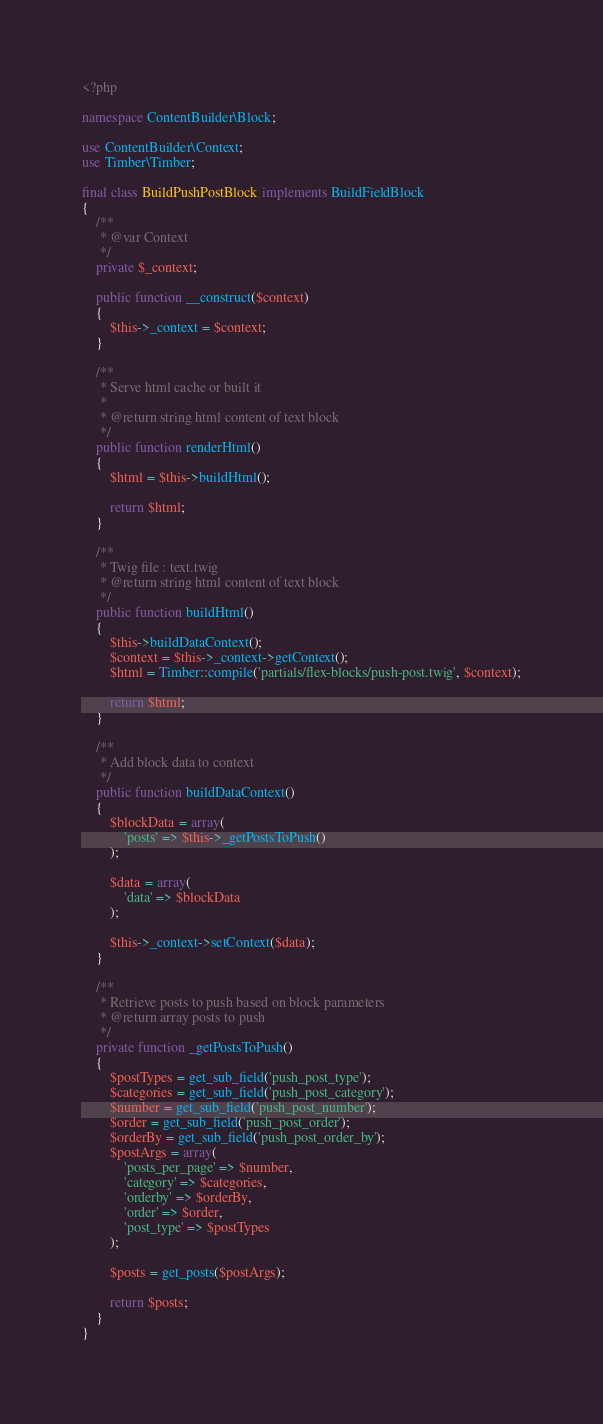Convert code to text. <code><loc_0><loc_0><loc_500><loc_500><_PHP_><?php

namespace ContentBuilder\Block;

use ContentBuilder\Context;
use Timber\Timber;

final class BuildPushPostBlock implements BuildFieldBlock
{
    /**
     * @var Context
     */
    private $_context;

    public function __construct($context)
    {
        $this->_context = $context;
    }

    /**
     * Serve html cache or built it
     *
     * @return string html content of text block
     */
    public function renderHtml()
    {
        $html = $this->buildHtml();

        return $html;
    }

    /**
     * Twig file : text.twig
     * @return string html content of text block
     */
    public function buildHtml()
    {
        $this->buildDataContext();
        $context = $this->_context->getContext();
        $html = Timber::compile('partials/flex-blocks/push-post.twig', $context);

        return $html;
    }

    /**
     * Add block data to context
     */
    public function buildDataContext()
    {
        $blockData = array(
            'posts' => $this->_getPostsToPush()
        );

        $data = array(
            'data' => $blockData
        );

        $this->_context->setContext($data);
    }

    /**
     * Retrieve posts to push based on block parameters
     * @return array posts to push
     */
    private function _getPostsToPush()
    {
        $postTypes = get_sub_field('push_post_type');
        $categories = get_sub_field('push_post_category');
        $number = get_sub_field('push_post_number');
        $order = get_sub_field('push_post_order');
        $orderBy = get_sub_field('push_post_order_by');
        $postArgs = array(
            'posts_per_page' => $number,
            'category' => $categories,
            'orderby' => $orderBy,
            'order' => $order,
            'post_type' => $postTypes
        );

        $posts = get_posts($postArgs);

        return $posts;
    }
}</code> 